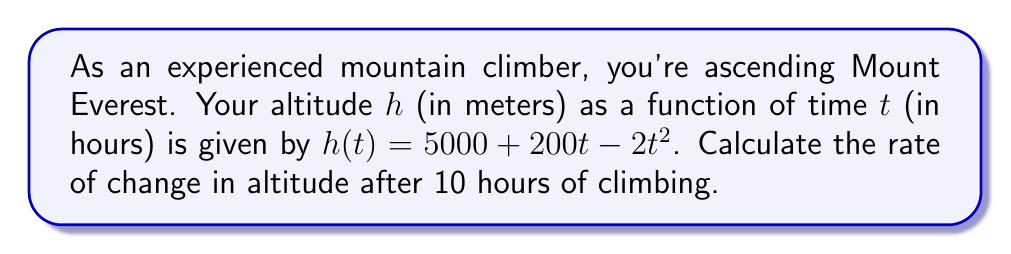What is the answer to this math problem? To find the rate of change in altitude at a specific time, we need to calculate the derivative of the altitude function and then evaluate it at the given time.

1. Given altitude function: $h(t) = 5000 + 200t - 2t^2$

2. Calculate the derivative $h'(t)$:
   $$h'(t) = \frac{d}{dt}(5000 + 200t - 2t^2)$$
   $$h'(t) = 0 + 200 - 4t$$
   $$h'(t) = 200 - 4t$$

3. Evaluate $h'(t)$ at $t = 10$ hours:
   $$h'(10) = 200 - 4(10)$$
   $$h'(10) = 200 - 40$$
   $$h'(10) = 160$$

The rate of change in altitude after 10 hours of climbing is 160 meters per hour.

Note: The positive value indicates you're still ascending, but at a slower rate than when you started due to the negative coefficient of $t^2$ in the original function.
Answer: $160$ m/h 